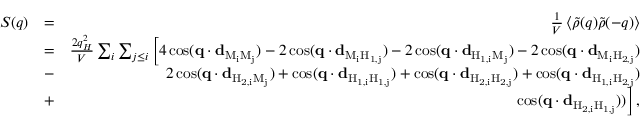Convert formula to latex. <formula><loc_0><loc_0><loc_500><loc_500>\begin{array} { r l r } { S ( q ) } & { = } & { \frac { 1 } { V } \left \langle \tilde { \rho } ( q ) \tilde { \rho } ( - q ) \right \rangle } \\ & { = } & { \frac { 2 q _ { H } ^ { 2 } } { V } \sum _ { i } \sum _ { j \leq i } \left [ 4 \cos ( q \cdot d _ { M _ { i } M _ { j } } ) - 2 \cos ( q \cdot d _ { M _ { i } H _ { 1 , j } } ) - 2 \cos ( q \cdot d _ { H _ { 1 , i } M _ { j } } ) - 2 \cos ( q \cdot d _ { M _ { i } H _ { 2 , j } } ) } \\ & { - } & { 2 \cos ( q \cdot d _ { H _ { 2 , i } M _ { j } } ) + \cos ( q \cdot d _ { H _ { 1 , i } H _ { 1 , j } } ) + \cos ( q \cdot d _ { H _ { 2 , i } H _ { 2 , j } } ) + \cos ( q \cdot d _ { H _ { 1 , i } H _ { 2 , j } } ) } \\ & { + } & { \cos ( q \cdot d _ { H _ { 2 , i } H _ { 1 , j } } ) ) \right ] \, , } \end{array}</formula> 